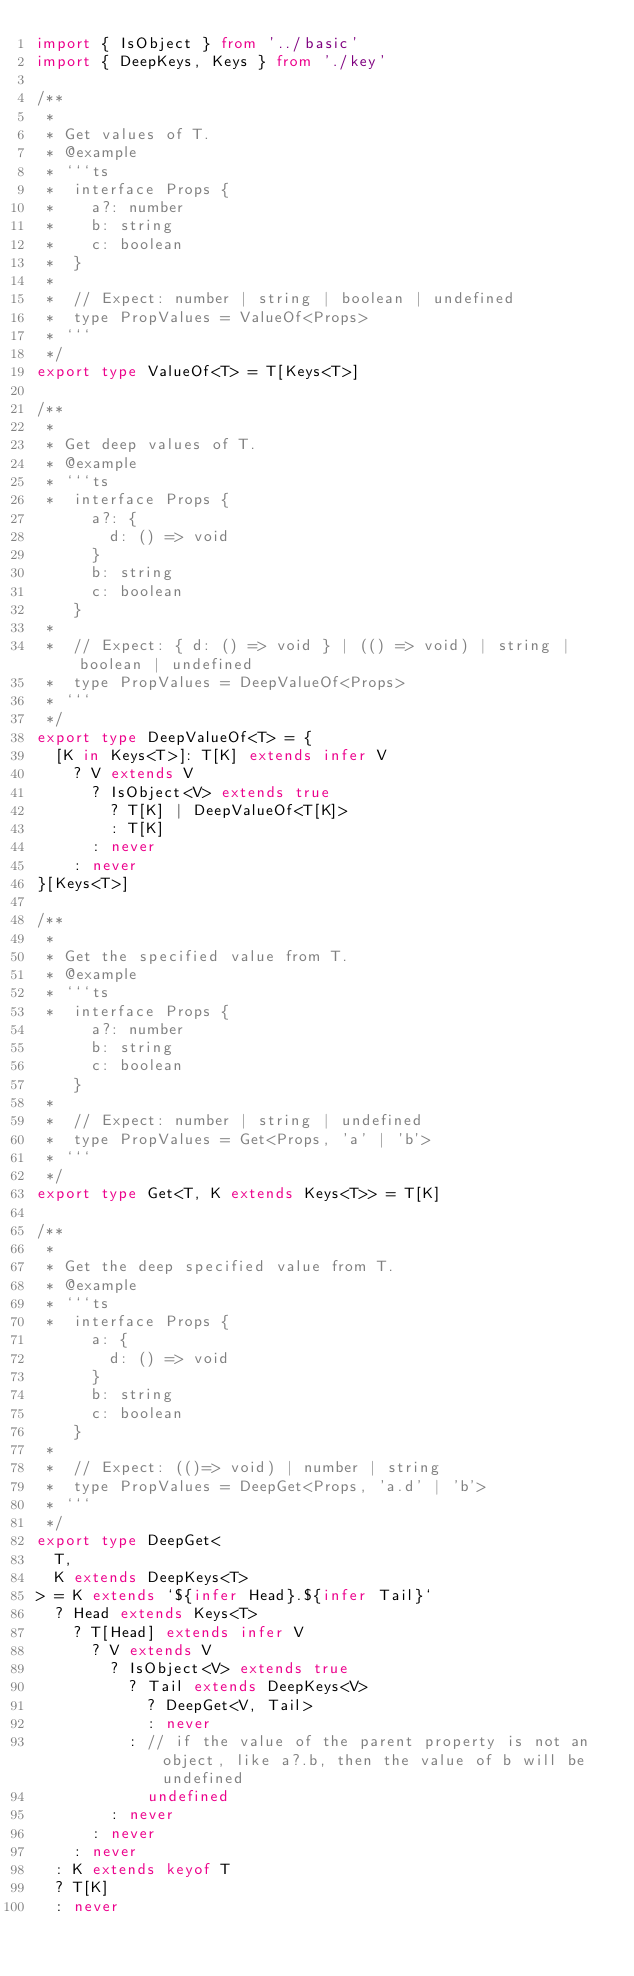<code> <loc_0><loc_0><loc_500><loc_500><_TypeScript_>import { IsObject } from '../basic'
import { DeepKeys, Keys } from './key'

/**
 *
 * Get values of T.
 * @example
 * ```ts
 *  interface Props {
 *    a?: number
 *    b: string
 *    c: boolean
 *  }
 *
 *  // Expect: number | string | boolean | undefined
 *  type PropValues = ValueOf<Props>
 * ```
 */
export type ValueOf<T> = T[Keys<T>]

/**
 *
 * Get deep values of T.
 * @example
 * ```ts
 *  interface Props {
      a?: {
        d: () => void
      }
      b: string
      c: boolean
    }
 *
 *  // Expect: { d: () => void } | (() => void) | string | boolean | undefined
 *  type PropValues = DeepValueOf<Props>
 * ```
 */
export type DeepValueOf<T> = {
  [K in Keys<T>]: T[K] extends infer V
    ? V extends V
      ? IsObject<V> extends true
        ? T[K] | DeepValueOf<T[K]>
        : T[K]
      : never
    : never
}[Keys<T>]

/**
 *
 * Get the specified value from T.
 * @example
 * ```ts
 *  interface Props {
      a?: number
      b: string
      c: boolean
    }
 *
 *  // Expect: number | string | undefined
 *  type PropValues = Get<Props, 'a' | 'b'>
 * ```
 */
export type Get<T, K extends Keys<T>> = T[K]

/**
 *
 * Get the deep specified value from T.
 * @example
 * ```ts
 *  interface Props {
      a: {
        d: () => void
      }
      b: string
      c: boolean
    }
 *
 *  // Expect: (()=> void) | number | string
 *  type PropValues = DeepGet<Props, 'a.d' | 'b'>
 * ```
 */
export type DeepGet<
  T,
  K extends DeepKeys<T>
> = K extends `${infer Head}.${infer Tail}`
  ? Head extends Keys<T>
    ? T[Head] extends infer V
      ? V extends V
        ? IsObject<V> extends true
          ? Tail extends DeepKeys<V>
            ? DeepGet<V, Tail>
            : never
          : // if the value of the parent property is not an object, like a?.b, then the value of b will be undefined
            undefined
        : never
      : never
    : never
  : K extends keyof T
  ? T[K]
  : never
</code> 